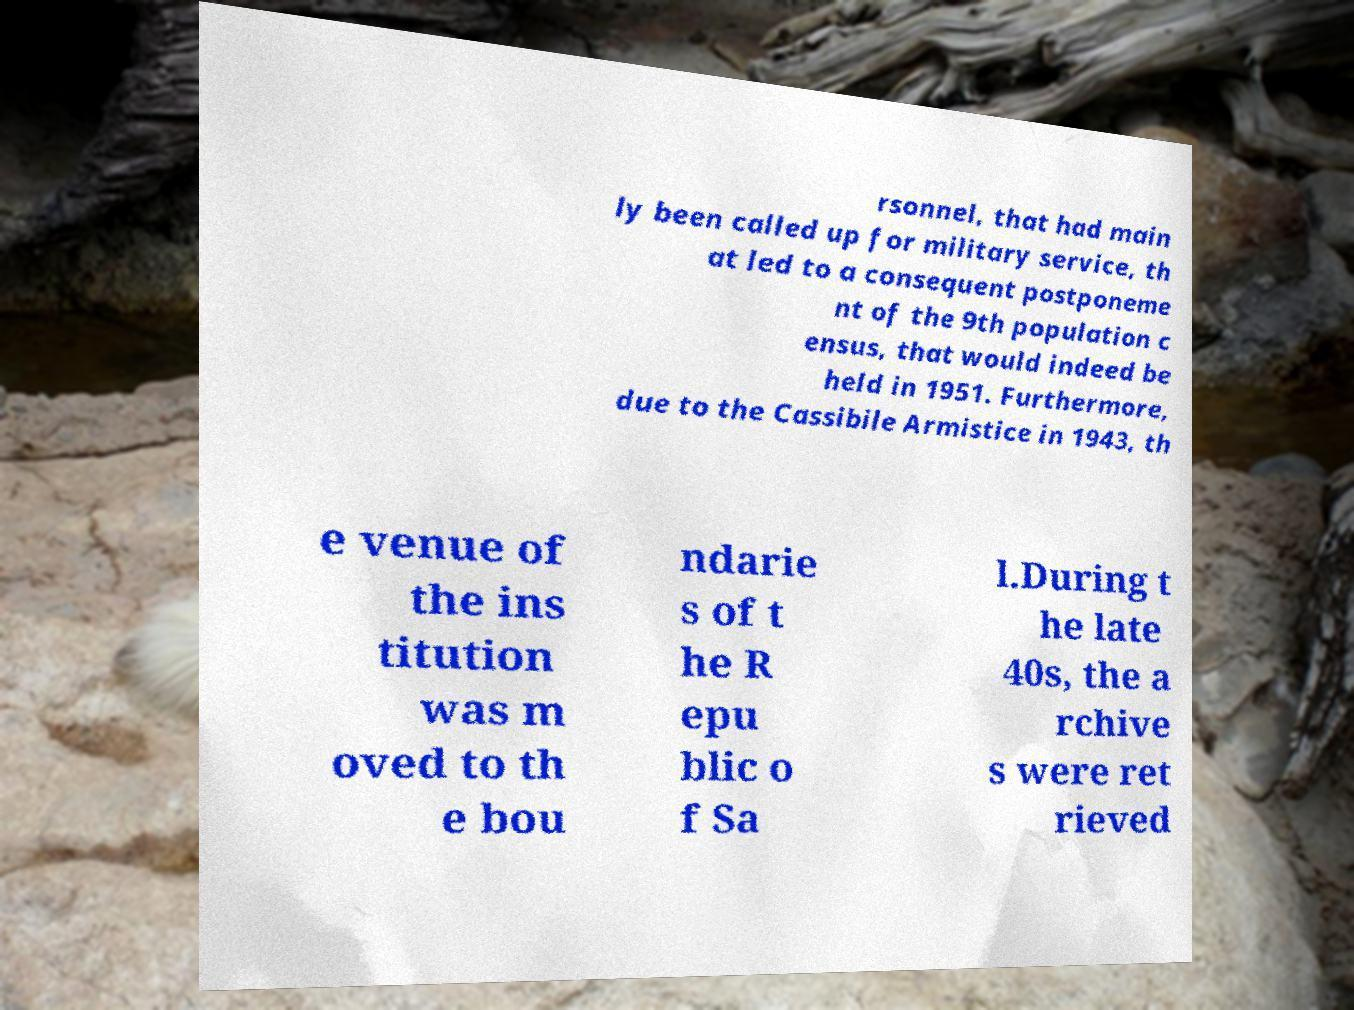For documentation purposes, I need the text within this image transcribed. Could you provide that? rsonnel, that had main ly been called up for military service, th at led to a consequent postponeme nt of the 9th population c ensus, that would indeed be held in 1951. Furthermore, due to the Cassibile Armistice in 1943, th e venue of the ins titution was m oved to th e bou ndarie s of t he R epu blic o f Sa l.During t he late 40s, the a rchive s were ret rieved 